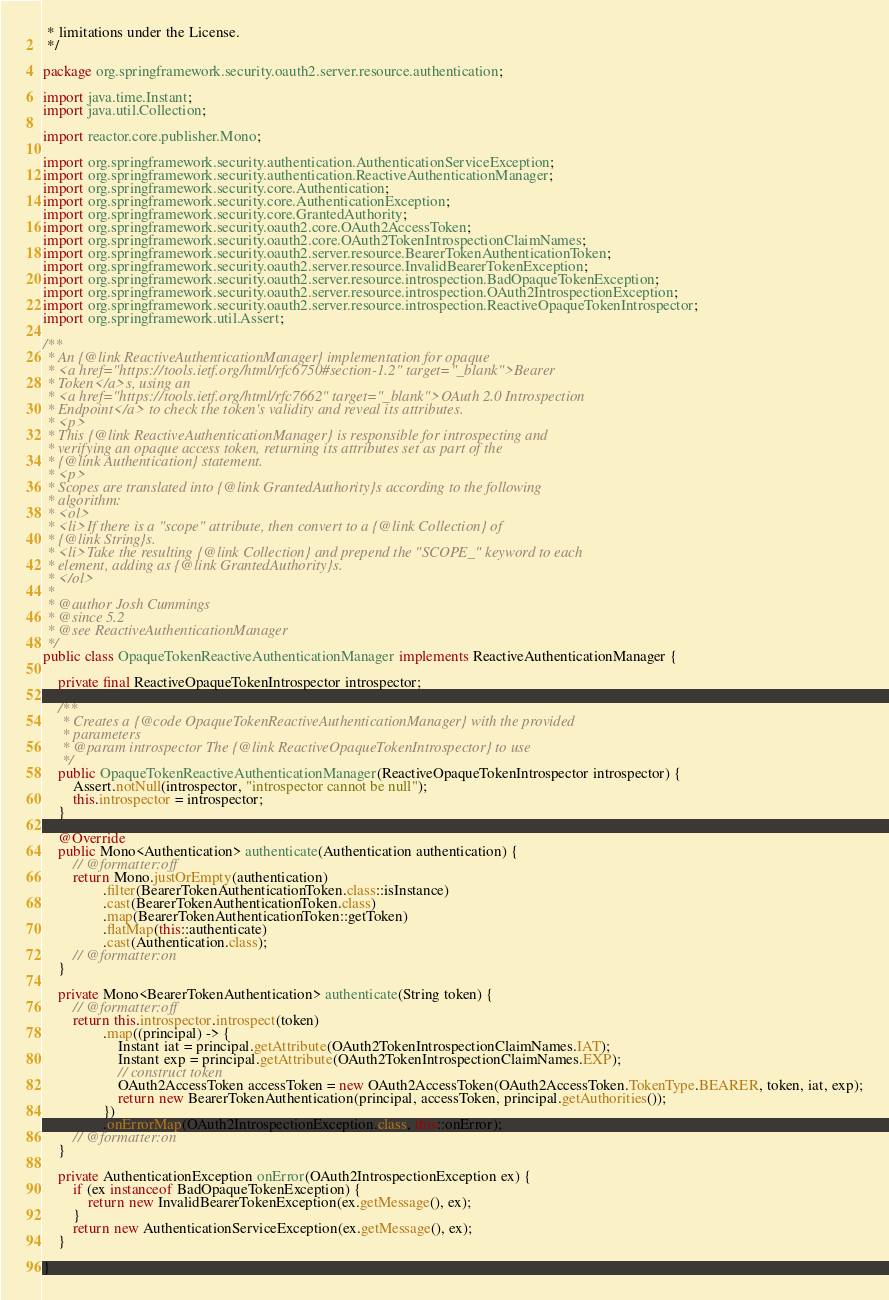Convert code to text. <code><loc_0><loc_0><loc_500><loc_500><_Java_> * limitations under the License.
 */

package org.springframework.security.oauth2.server.resource.authentication;

import java.time.Instant;
import java.util.Collection;

import reactor.core.publisher.Mono;

import org.springframework.security.authentication.AuthenticationServiceException;
import org.springframework.security.authentication.ReactiveAuthenticationManager;
import org.springframework.security.core.Authentication;
import org.springframework.security.core.AuthenticationException;
import org.springframework.security.core.GrantedAuthority;
import org.springframework.security.oauth2.core.OAuth2AccessToken;
import org.springframework.security.oauth2.core.OAuth2TokenIntrospectionClaimNames;
import org.springframework.security.oauth2.server.resource.BearerTokenAuthenticationToken;
import org.springframework.security.oauth2.server.resource.InvalidBearerTokenException;
import org.springframework.security.oauth2.server.resource.introspection.BadOpaqueTokenException;
import org.springframework.security.oauth2.server.resource.introspection.OAuth2IntrospectionException;
import org.springframework.security.oauth2.server.resource.introspection.ReactiveOpaqueTokenIntrospector;
import org.springframework.util.Assert;

/**
 * An {@link ReactiveAuthenticationManager} implementation for opaque
 * <a href="https://tools.ietf.org/html/rfc6750#section-1.2" target="_blank">Bearer
 * Token</a>s, using an
 * <a href="https://tools.ietf.org/html/rfc7662" target="_blank">OAuth 2.0 Introspection
 * Endpoint</a> to check the token's validity and reveal its attributes.
 * <p>
 * This {@link ReactiveAuthenticationManager} is responsible for introspecting and
 * verifying an opaque access token, returning its attributes set as part of the
 * {@link Authentication} statement.
 * <p>
 * Scopes are translated into {@link GrantedAuthority}s according to the following
 * algorithm:
 * <ol>
 * <li>If there is a "scope" attribute, then convert to a {@link Collection} of
 * {@link String}s.
 * <li>Take the resulting {@link Collection} and prepend the "SCOPE_" keyword to each
 * element, adding as {@link GrantedAuthority}s.
 * </ol>
 *
 * @author Josh Cummings
 * @since 5.2
 * @see ReactiveAuthenticationManager
 */
public class OpaqueTokenReactiveAuthenticationManager implements ReactiveAuthenticationManager {

	private final ReactiveOpaqueTokenIntrospector introspector;

	/**
	 * Creates a {@code OpaqueTokenReactiveAuthenticationManager} with the provided
	 * parameters
	 * @param introspector The {@link ReactiveOpaqueTokenIntrospector} to use
	 */
	public OpaqueTokenReactiveAuthenticationManager(ReactiveOpaqueTokenIntrospector introspector) {
		Assert.notNull(introspector, "introspector cannot be null");
		this.introspector = introspector;
	}

	@Override
	public Mono<Authentication> authenticate(Authentication authentication) {
		// @formatter:off
		return Mono.justOrEmpty(authentication)
				.filter(BearerTokenAuthenticationToken.class::isInstance)
				.cast(BearerTokenAuthenticationToken.class)
				.map(BearerTokenAuthenticationToken::getToken)
				.flatMap(this::authenticate)
				.cast(Authentication.class);
		// @formatter:on
	}

	private Mono<BearerTokenAuthentication> authenticate(String token) {
		// @formatter:off
		return this.introspector.introspect(token)
				.map((principal) -> {
					Instant iat = principal.getAttribute(OAuth2TokenIntrospectionClaimNames.IAT);
					Instant exp = principal.getAttribute(OAuth2TokenIntrospectionClaimNames.EXP);
					// construct token
					OAuth2AccessToken accessToken = new OAuth2AccessToken(OAuth2AccessToken.TokenType.BEARER, token, iat, exp);
					return new BearerTokenAuthentication(principal, accessToken, principal.getAuthorities());
				})
				.onErrorMap(OAuth2IntrospectionException.class, this::onError);
		// @formatter:on
	}

	private AuthenticationException onError(OAuth2IntrospectionException ex) {
		if (ex instanceof BadOpaqueTokenException) {
			return new InvalidBearerTokenException(ex.getMessage(), ex);
		}
		return new AuthenticationServiceException(ex.getMessage(), ex);
	}

}
</code> 